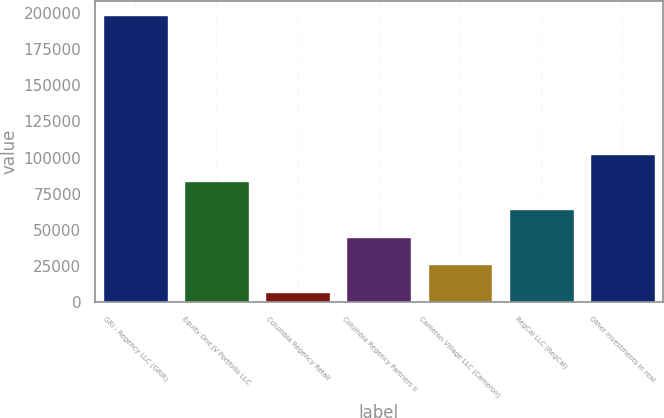Convert chart. <chart><loc_0><loc_0><loc_500><loc_500><bar_chart><fcel>GRI - Regency LLC (GRIR)<fcel>Equity One JV Portfolio LLC<fcel>Columbia Regency Retail<fcel>Columbia Regency Partners II<fcel>Cameron Village LLC (Cameron)<fcel>RegCal LLC (RegCal)<fcel>Other investments in real<nl><fcel>198521<fcel>83642.6<fcel>7057<fcel>45349.8<fcel>26203.4<fcel>64496.2<fcel>102789<nl></chart> 